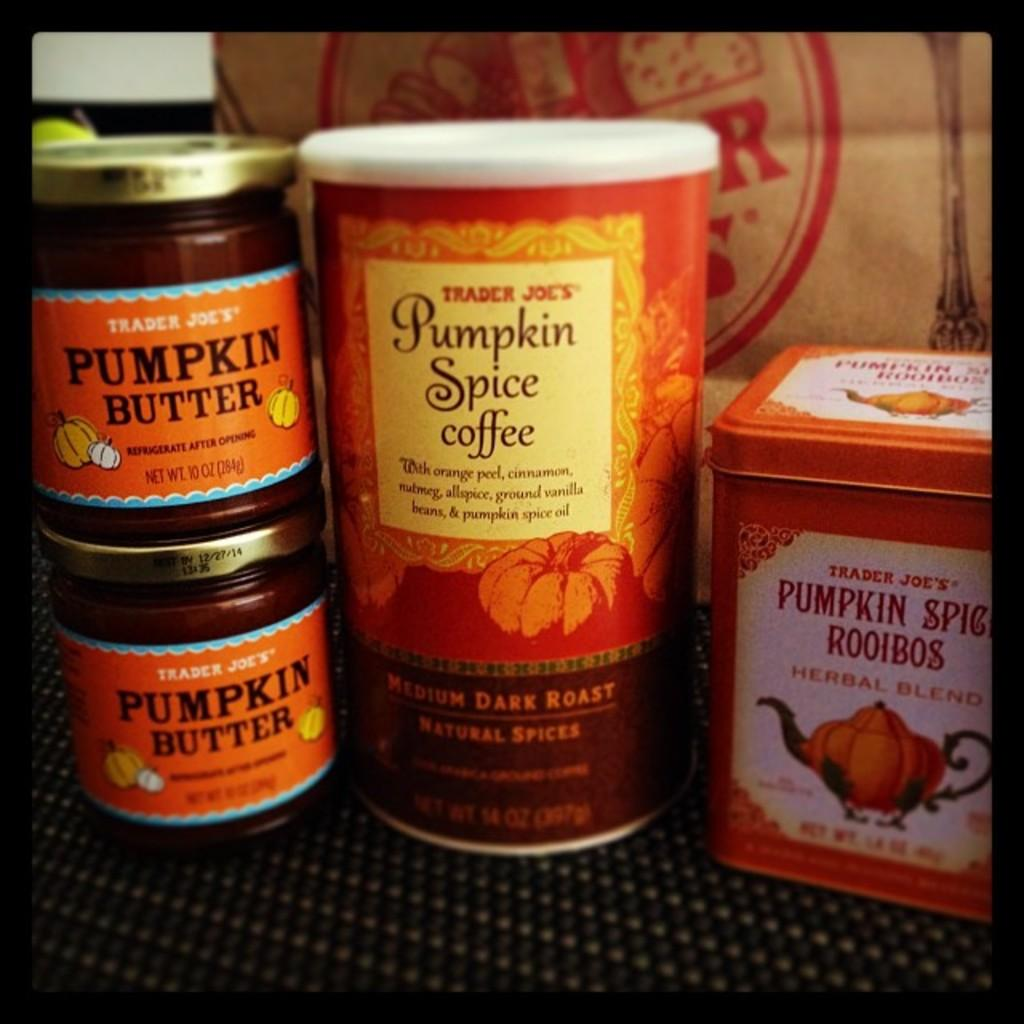<image>
Write a terse but informative summary of the picture. A group of jars that say Pumpkin Butter and a can of Pumpkin Spice Coffee. 